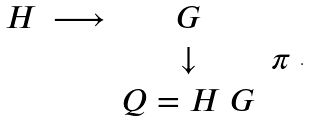<formula> <loc_0><loc_0><loc_500><loc_500>\begin{array} { c c c c } H & \longrightarrow & G & \\ & & \downarrow & \pi \\ & & Q = H \ G & \end{array} .</formula> 